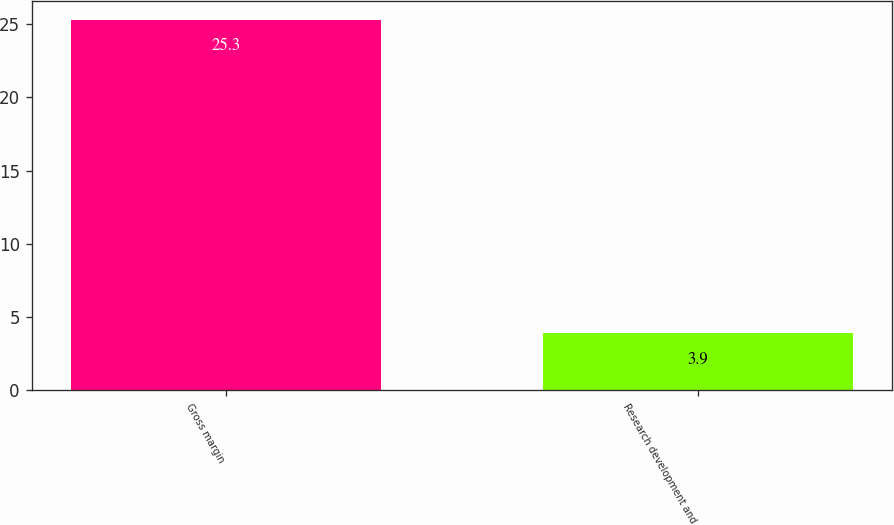<chart> <loc_0><loc_0><loc_500><loc_500><bar_chart><fcel>Gross margin<fcel>Research development and<nl><fcel>25.3<fcel>3.9<nl></chart> 